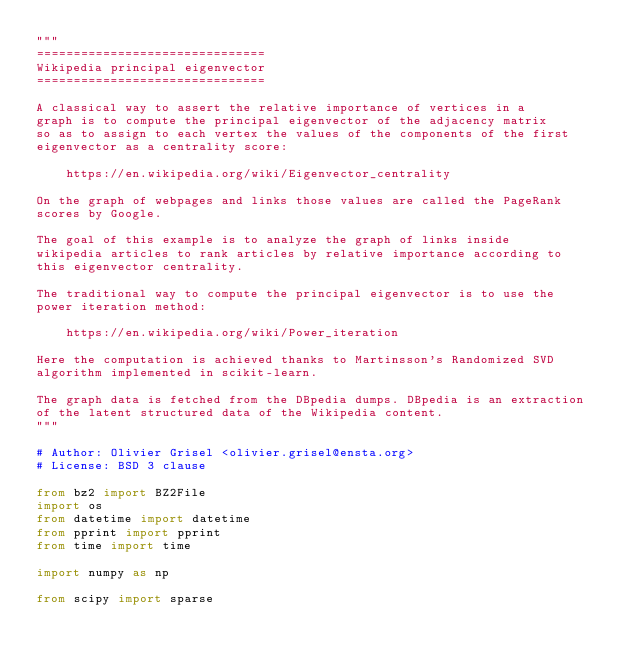Convert code to text. <code><loc_0><loc_0><loc_500><loc_500><_Python_>"""
===============================
Wikipedia principal eigenvector
===============================

A classical way to assert the relative importance of vertices in a
graph is to compute the principal eigenvector of the adjacency matrix
so as to assign to each vertex the values of the components of the first
eigenvector as a centrality score:

    https://en.wikipedia.org/wiki/Eigenvector_centrality

On the graph of webpages and links those values are called the PageRank
scores by Google.

The goal of this example is to analyze the graph of links inside
wikipedia articles to rank articles by relative importance according to
this eigenvector centrality.

The traditional way to compute the principal eigenvector is to use the
power iteration method:

    https://en.wikipedia.org/wiki/Power_iteration

Here the computation is achieved thanks to Martinsson's Randomized SVD
algorithm implemented in scikit-learn.

The graph data is fetched from the DBpedia dumps. DBpedia is an extraction
of the latent structured data of the Wikipedia content.
"""

# Author: Olivier Grisel <olivier.grisel@ensta.org>
# License: BSD 3 clause

from bz2 import BZ2File
import os
from datetime import datetime
from pprint import pprint
from time import time

import numpy as np

from scipy import sparse
</code> 